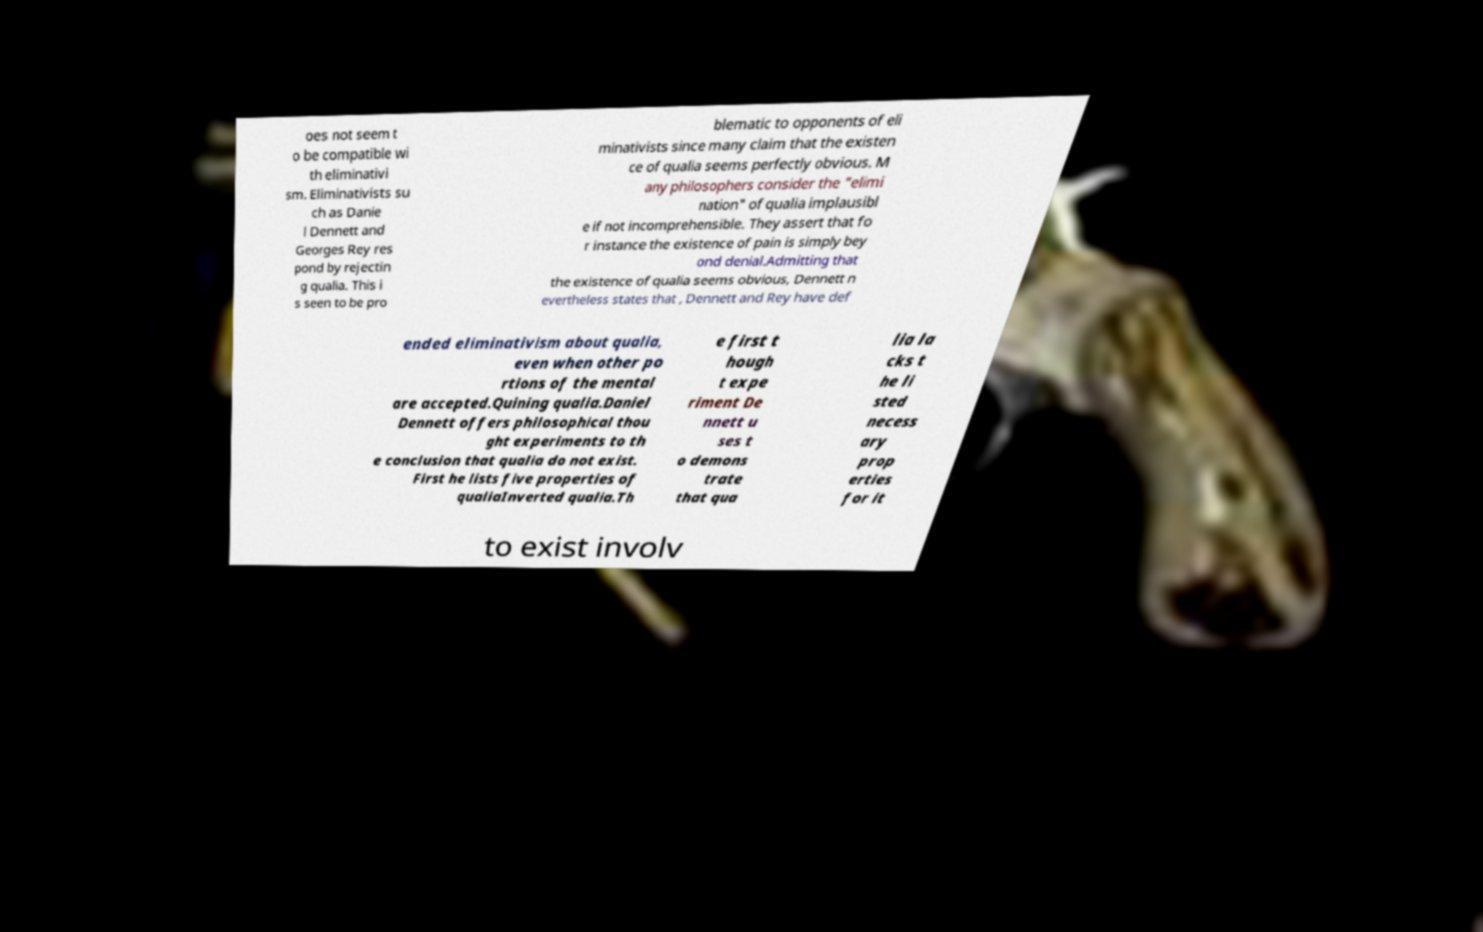Could you assist in decoding the text presented in this image and type it out clearly? oes not seem t o be compatible wi th eliminativi sm. Eliminativists su ch as Danie l Dennett and Georges Rey res pond by rejectin g qualia. This i s seen to be pro blematic to opponents of eli minativists since many claim that the existen ce of qualia seems perfectly obvious. M any philosophers consider the "elimi nation" of qualia implausibl e if not incomprehensible. They assert that fo r instance the existence of pain is simply bey ond denial.Admitting that the existence of qualia seems obvious, Dennett n evertheless states that , Dennett and Rey have def ended eliminativism about qualia, even when other po rtions of the mental are accepted.Quining qualia.Daniel Dennett offers philosophical thou ght experiments to th e conclusion that qualia do not exist. First he lists five properties of qualiaInverted qualia.Th e first t hough t expe riment De nnett u ses t o demons trate that qua lia la cks t he li sted necess ary prop erties for it to exist involv 